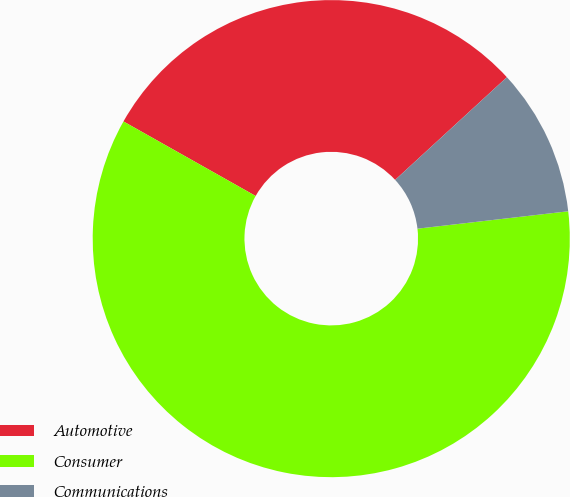Convert chart to OTSL. <chart><loc_0><loc_0><loc_500><loc_500><pie_chart><fcel>Automotive<fcel>Consumer<fcel>Communications<nl><fcel>30.0%<fcel>60.0%<fcel>10.0%<nl></chart> 